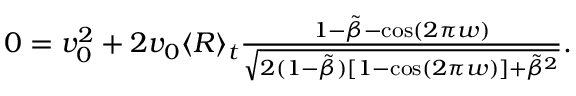<formula> <loc_0><loc_0><loc_500><loc_500>\begin{array} { r } { 0 = v _ { 0 } ^ { 2 } + 2 v _ { 0 } \langle R \rangle _ { t } \frac { 1 - \tilde { \beta } - \cos ( 2 \pi w ) } { \sqrt { 2 ( 1 - \tilde { \beta } ) [ 1 - \cos ( 2 \pi w ) ] + \tilde { \beta } ^ { 2 } } } . } \end{array}</formula> 